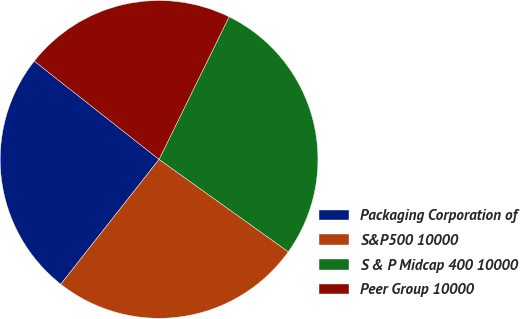<chart> <loc_0><loc_0><loc_500><loc_500><pie_chart><fcel>Packaging Corporation of<fcel>S&P500 10000<fcel>S & P Midcap 400 10000<fcel>Peer Group 10000<nl><fcel>25.0%<fcel>25.74%<fcel>27.61%<fcel>21.65%<nl></chart> 